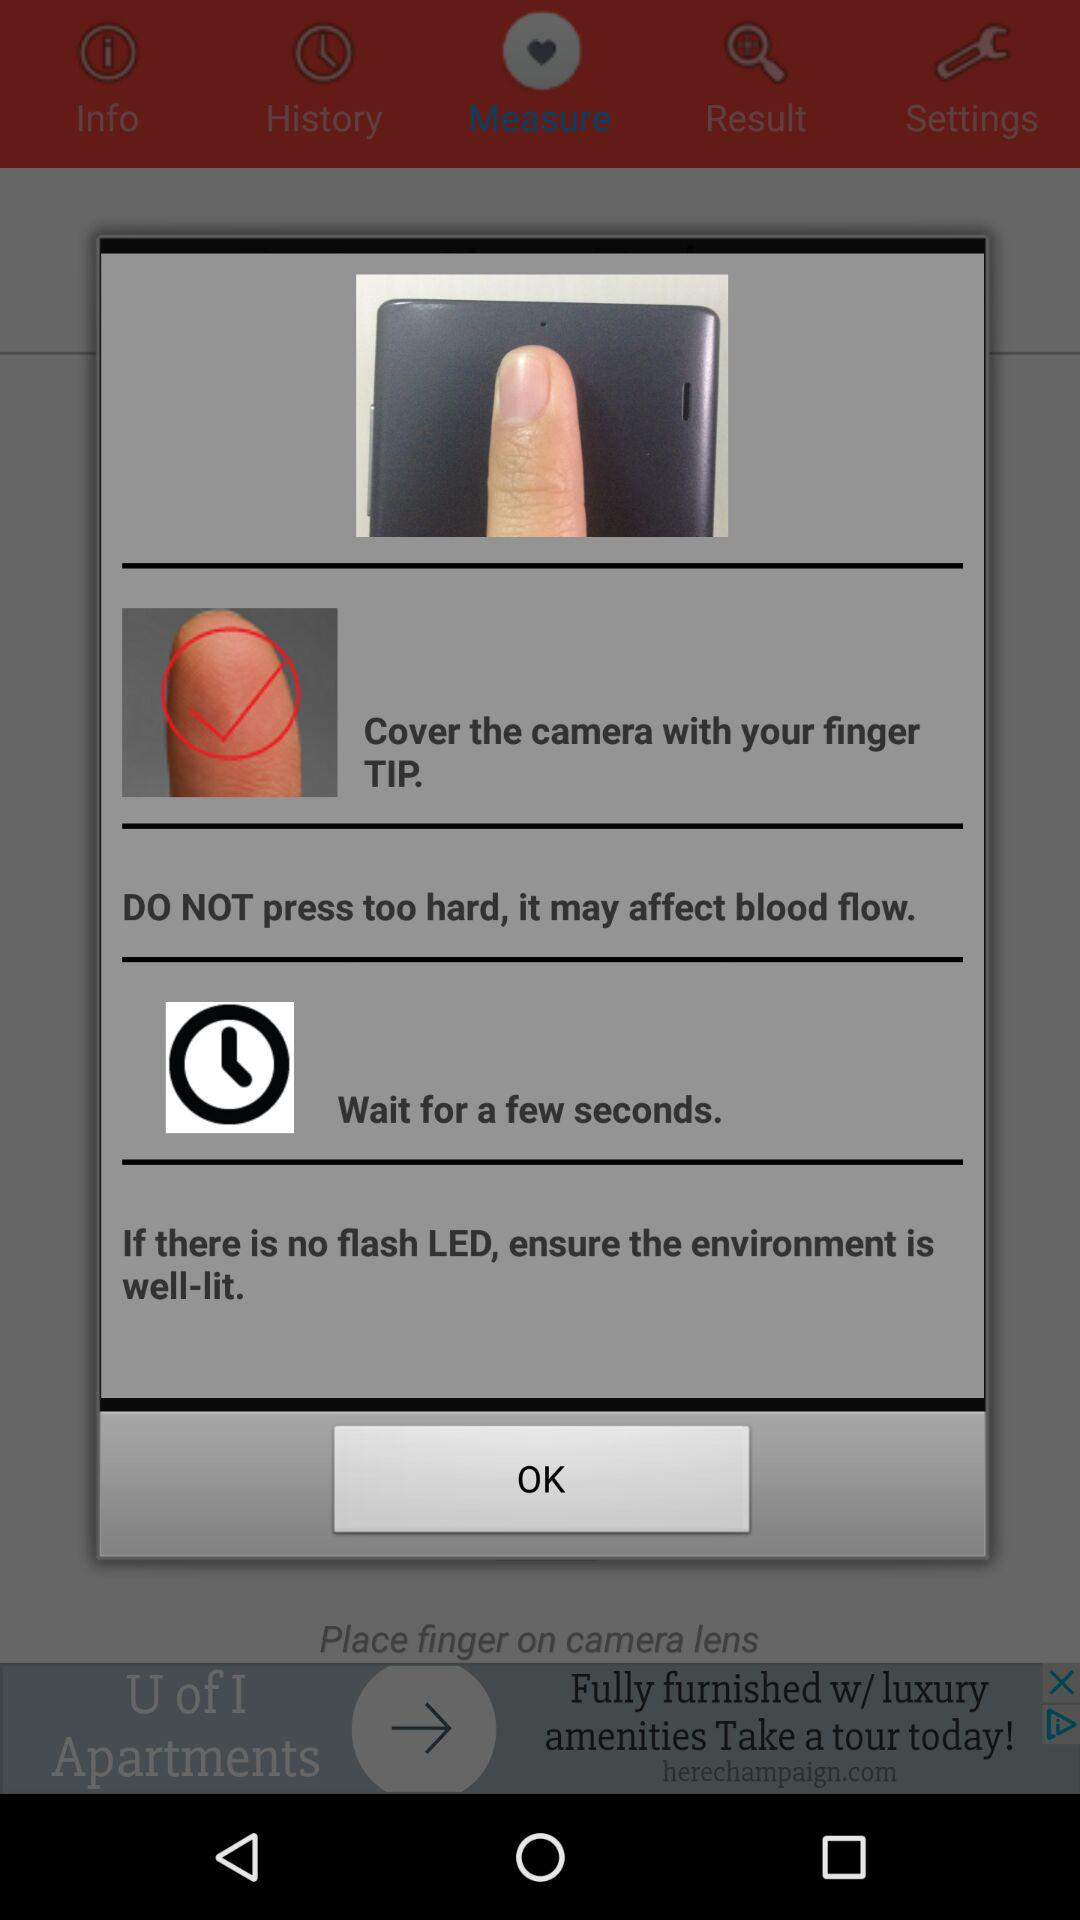How many seconds should I wait after covering the camera with my finger?
Answer the question using a single word or phrase. A few seconds 